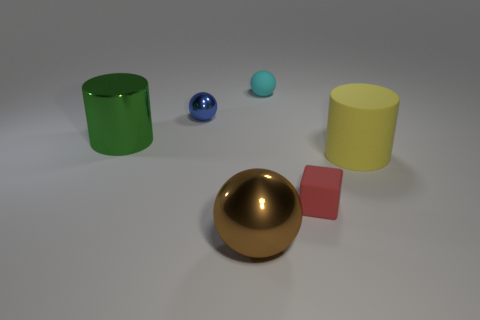What shape is the tiny red object?
Your response must be concise. Cube. There is a cyan rubber thing that is behind the cylinder that is on the left side of the tiny cyan rubber ball; how many small cyan matte objects are behind it?
Provide a short and direct response. 0. What number of other objects are the same material as the large green thing?
Offer a terse response. 2. What is the material of the green cylinder that is the same size as the yellow cylinder?
Make the answer very short. Metal. There is a shiny sphere in front of the blue shiny ball; is it the same color as the tiny sphere that is right of the large brown shiny object?
Give a very brief answer. No. Is there a tiny matte thing that has the same shape as the large yellow rubber object?
Provide a succinct answer. No. What shape is the brown shiny object that is the same size as the yellow rubber object?
Your answer should be compact. Sphere. What number of matte cylinders have the same color as the cube?
Give a very brief answer. 0. There is a cylinder that is right of the small matte ball; what is its size?
Keep it short and to the point. Large. How many yellow rubber cylinders have the same size as the green cylinder?
Your answer should be very brief. 1. 